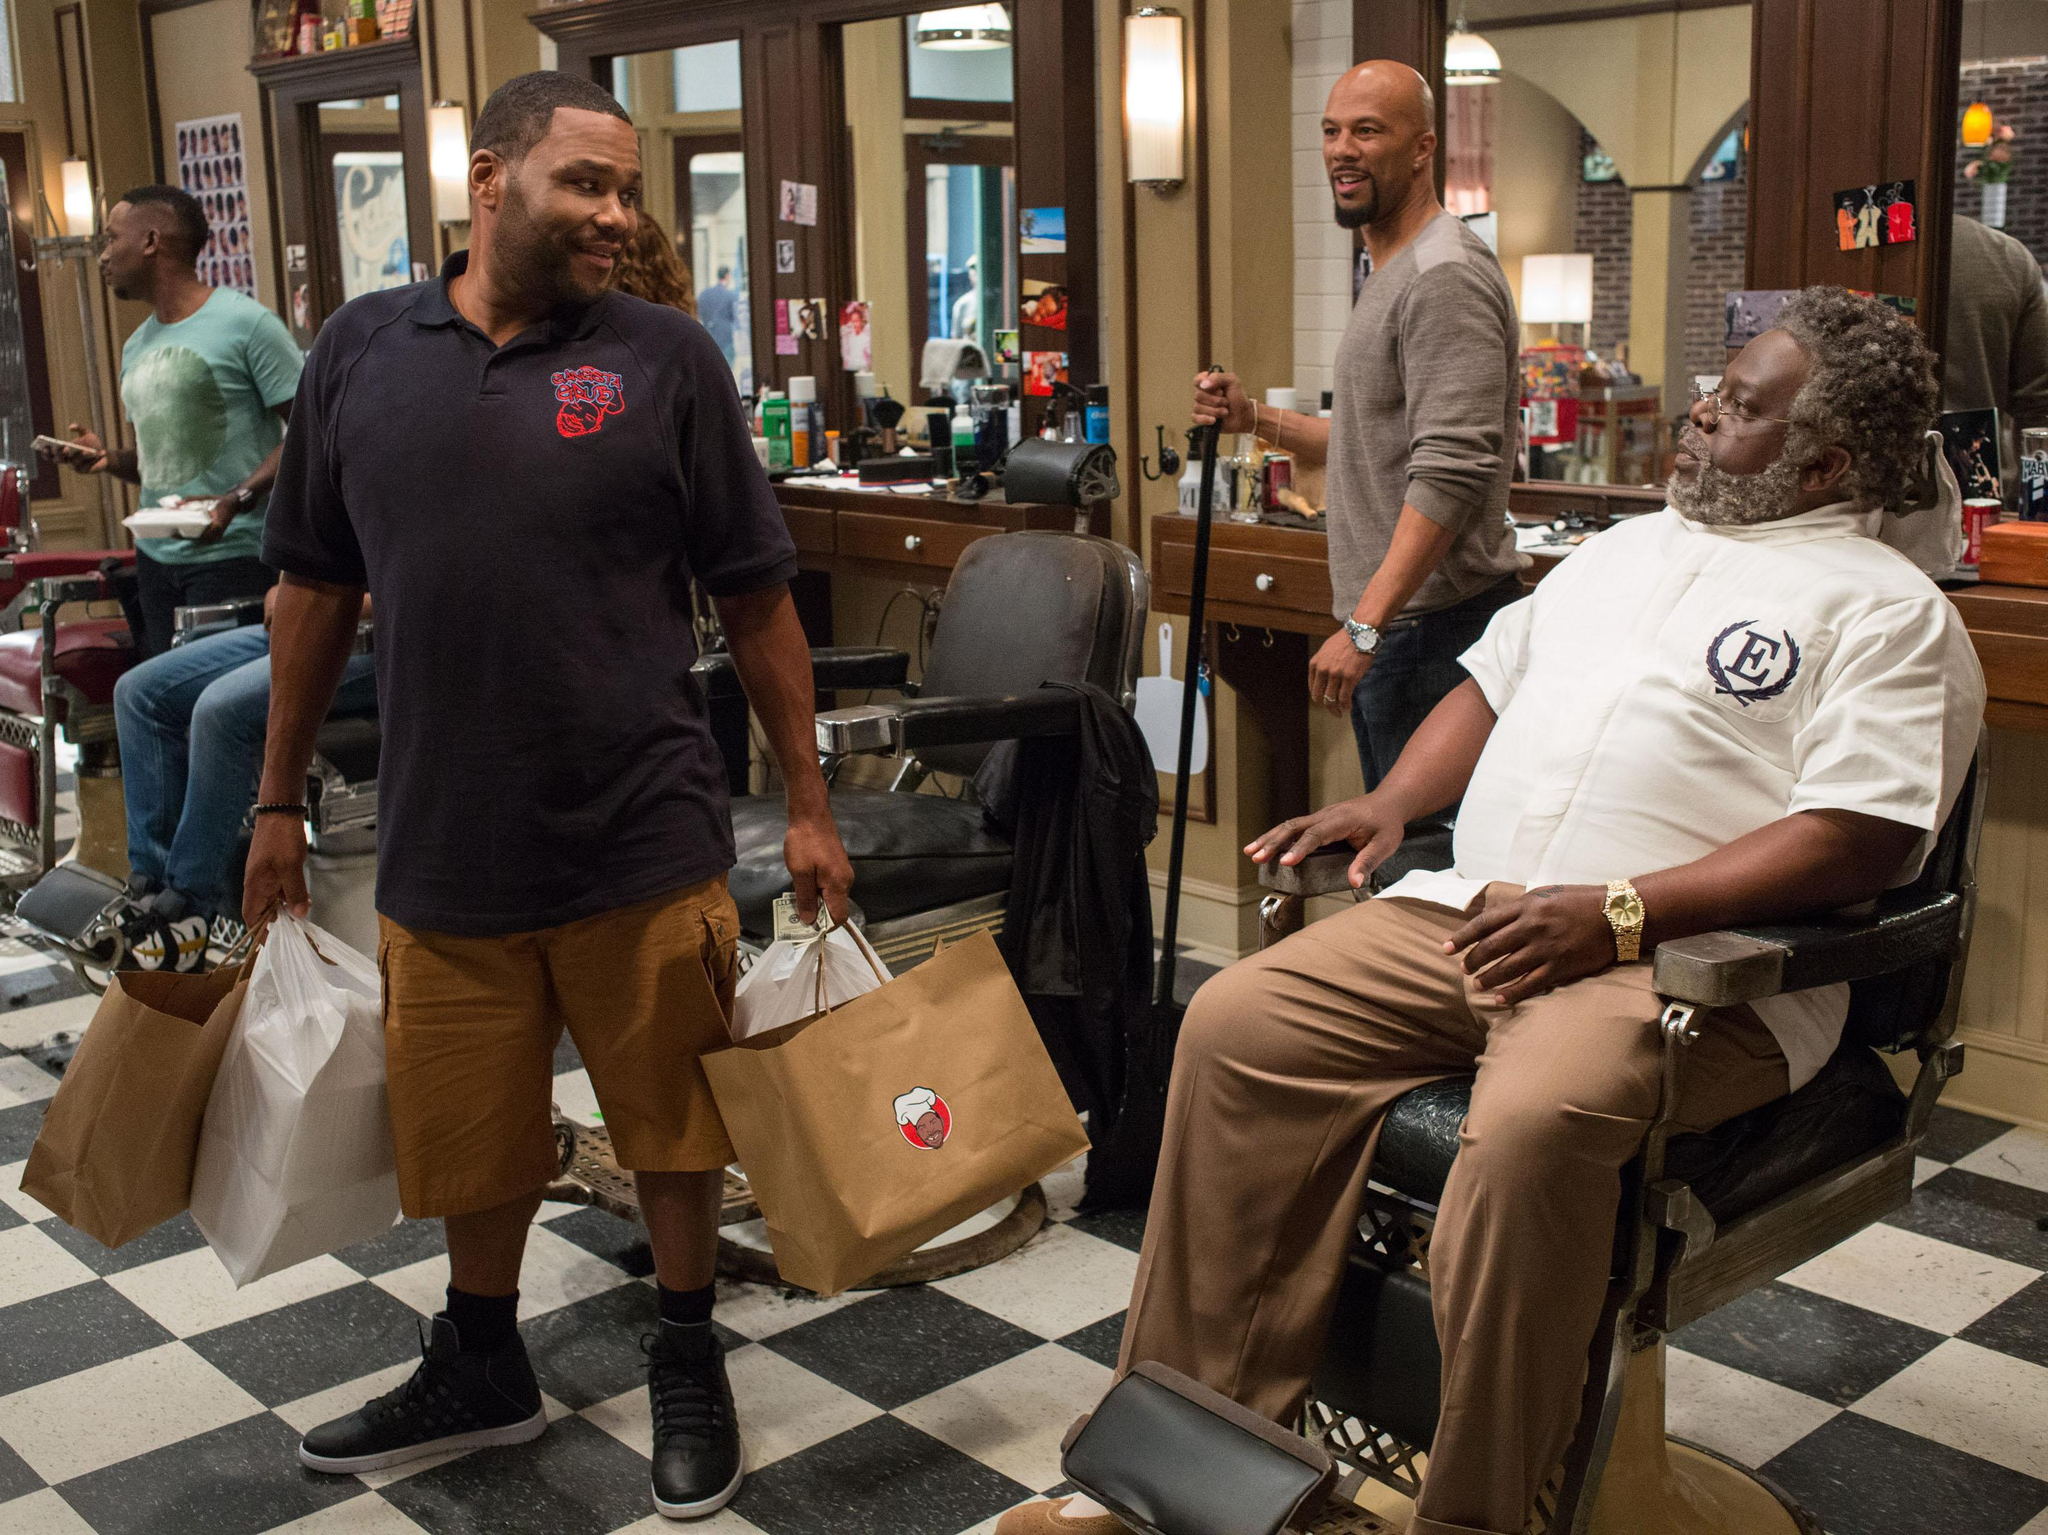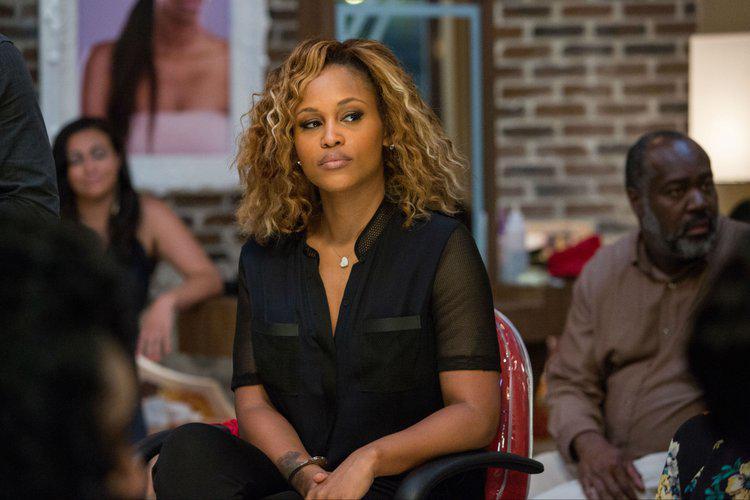The first image is the image on the left, the second image is the image on the right. Evaluate the accuracy of this statement regarding the images: "An image includes a black man with grizzled gray hair and beard, wearing a white top and khaki pants, and sitting in a barber chair.". Is it true? Answer yes or no. Yes. 